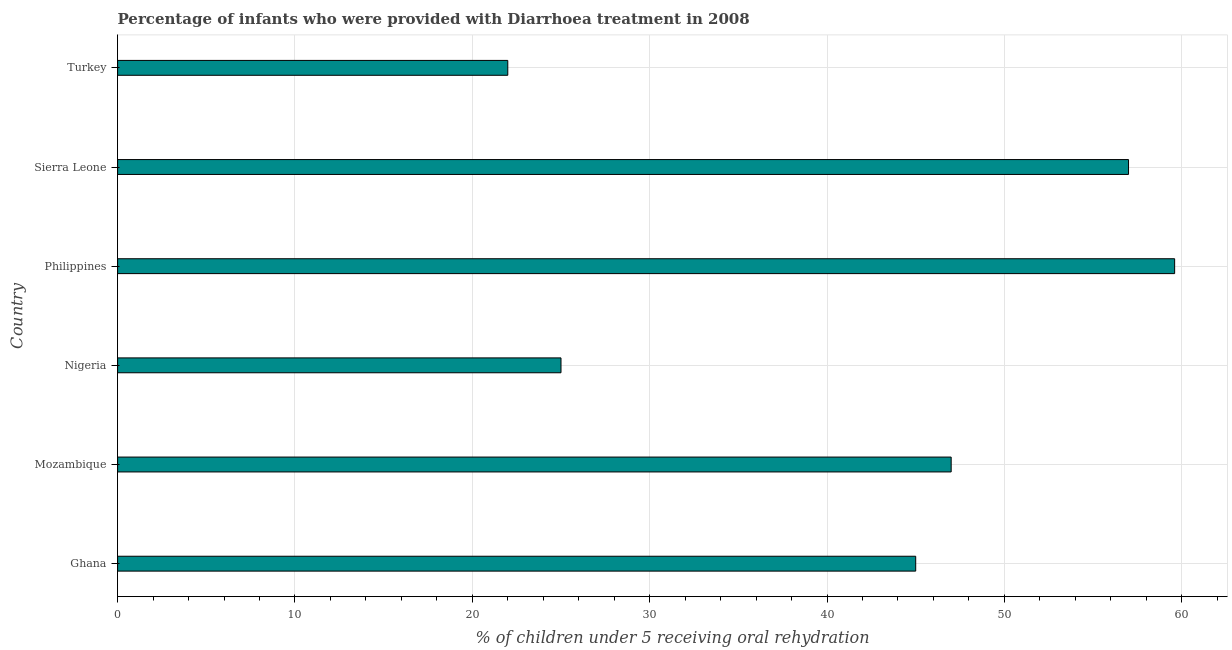Does the graph contain any zero values?
Offer a terse response. No. What is the title of the graph?
Provide a succinct answer. Percentage of infants who were provided with Diarrhoea treatment in 2008. What is the label or title of the X-axis?
Keep it short and to the point. % of children under 5 receiving oral rehydration. What is the label or title of the Y-axis?
Your answer should be compact. Country. Across all countries, what is the maximum percentage of children who were provided with treatment diarrhoea?
Keep it short and to the point. 59.6. In which country was the percentage of children who were provided with treatment diarrhoea maximum?
Your answer should be very brief. Philippines. In which country was the percentage of children who were provided with treatment diarrhoea minimum?
Ensure brevity in your answer.  Turkey. What is the sum of the percentage of children who were provided with treatment diarrhoea?
Ensure brevity in your answer.  255.6. What is the difference between the percentage of children who were provided with treatment diarrhoea in Nigeria and Turkey?
Offer a very short reply. 3. What is the average percentage of children who were provided with treatment diarrhoea per country?
Your answer should be compact. 42.6. In how many countries, is the percentage of children who were provided with treatment diarrhoea greater than 34 %?
Your answer should be very brief. 4. What is the ratio of the percentage of children who were provided with treatment diarrhoea in Mozambique to that in Philippines?
Offer a very short reply. 0.79. Is the difference between the percentage of children who were provided with treatment diarrhoea in Ghana and Philippines greater than the difference between any two countries?
Provide a succinct answer. No. What is the difference between the highest and the second highest percentage of children who were provided with treatment diarrhoea?
Ensure brevity in your answer.  2.6. Is the sum of the percentage of children who were provided with treatment diarrhoea in Ghana and Sierra Leone greater than the maximum percentage of children who were provided with treatment diarrhoea across all countries?
Give a very brief answer. Yes. What is the difference between the highest and the lowest percentage of children who were provided with treatment diarrhoea?
Keep it short and to the point. 37.6. In how many countries, is the percentage of children who were provided with treatment diarrhoea greater than the average percentage of children who were provided with treatment diarrhoea taken over all countries?
Your answer should be compact. 4. What is the difference between two consecutive major ticks on the X-axis?
Your answer should be very brief. 10. Are the values on the major ticks of X-axis written in scientific E-notation?
Your answer should be compact. No. What is the % of children under 5 receiving oral rehydration of Ghana?
Keep it short and to the point. 45. What is the % of children under 5 receiving oral rehydration in Nigeria?
Provide a short and direct response. 25. What is the % of children under 5 receiving oral rehydration in Philippines?
Your response must be concise. 59.6. What is the difference between the % of children under 5 receiving oral rehydration in Ghana and Nigeria?
Provide a succinct answer. 20. What is the difference between the % of children under 5 receiving oral rehydration in Ghana and Philippines?
Offer a terse response. -14.6. What is the difference between the % of children under 5 receiving oral rehydration in Ghana and Turkey?
Provide a short and direct response. 23. What is the difference between the % of children under 5 receiving oral rehydration in Mozambique and Philippines?
Your answer should be very brief. -12.6. What is the difference between the % of children under 5 receiving oral rehydration in Mozambique and Turkey?
Your response must be concise. 25. What is the difference between the % of children under 5 receiving oral rehydration in Nigeria and Philippines?
Offer a terse response. -34.6. What is the difference between the % of children under 5 receiving oral rehydration in Nigeria and Sierra Leone?
Keep it short and to the point. -32. What is the difference between the % of children under 5 receiving oral rehydration in Nigeria and Turkey?
Your answer should be very brief. 3. What is the difference between the % of children under 5 receiving oral rehydration in Philippines and Turkey?
Provide a short and direct response. 37.6. What is the ratio of the % of children under 5 receiving oral rehydration in Ghana to that in Philippines?
Keep it short and to the point. 0.76. What is the ratio of the % of children under 5 receiving oral rehydration in Ghana to that in Sierra Leone?
Make the answer very short. 0.79. What is the ratio of the % of children under 5 receiving oral rehydration in Ghana to that in Turkey?
Keep it short and to the point. 2.04. What is the ratio of the % of children under 5 receiving oral rehydration in Mozambique to that in Nigeria?
Your response must be concise. 1.88. What is the ratio of the % of children under 5 receiving oral rehydration in Mozambique to that in Philippines?
Keep it short and to the point. 0.79. What is the ratio of the % of children under 5 receiving oral rehydration in Mozambique to that in Sierra Leone?
Your answer should be compact. 0.82. What is the ratio of the % of children under 5 receiving oral rehydration in Mozambique to that in Turkey?
Your answer should be very brief. 2.14. What is the ratio of the % of children under 5 receiving oral rehydration in Nigeria to that in Philippines?
Provide a succinct answer. 0.42. What is the ratio of the % of children under 5 receiving oral rehydration in Nigeria to that in Sierra Leone?
Provide a short and direct response. 0.44. What is the ratio of the % of children under 5 receiving oral rehydration in Nigeria to that in Turkey?
Ensure brevity in your answer.  1.14. What is the ratio of the % of children under 5 receiving oral rehydration in Philippines to that in Sierra Leone?
Your answer should be compact. 1.05. What is the ratio of the % of children under 5 receiving oral rehydration in Philippines to that in Turkey?
Offer a terse response. 2.71. What is the ratio of the % of children under 5 receiving oral rehydration in Sierra Leone to that in Turkey?
Ensure brevity in your answer.  2.59. 